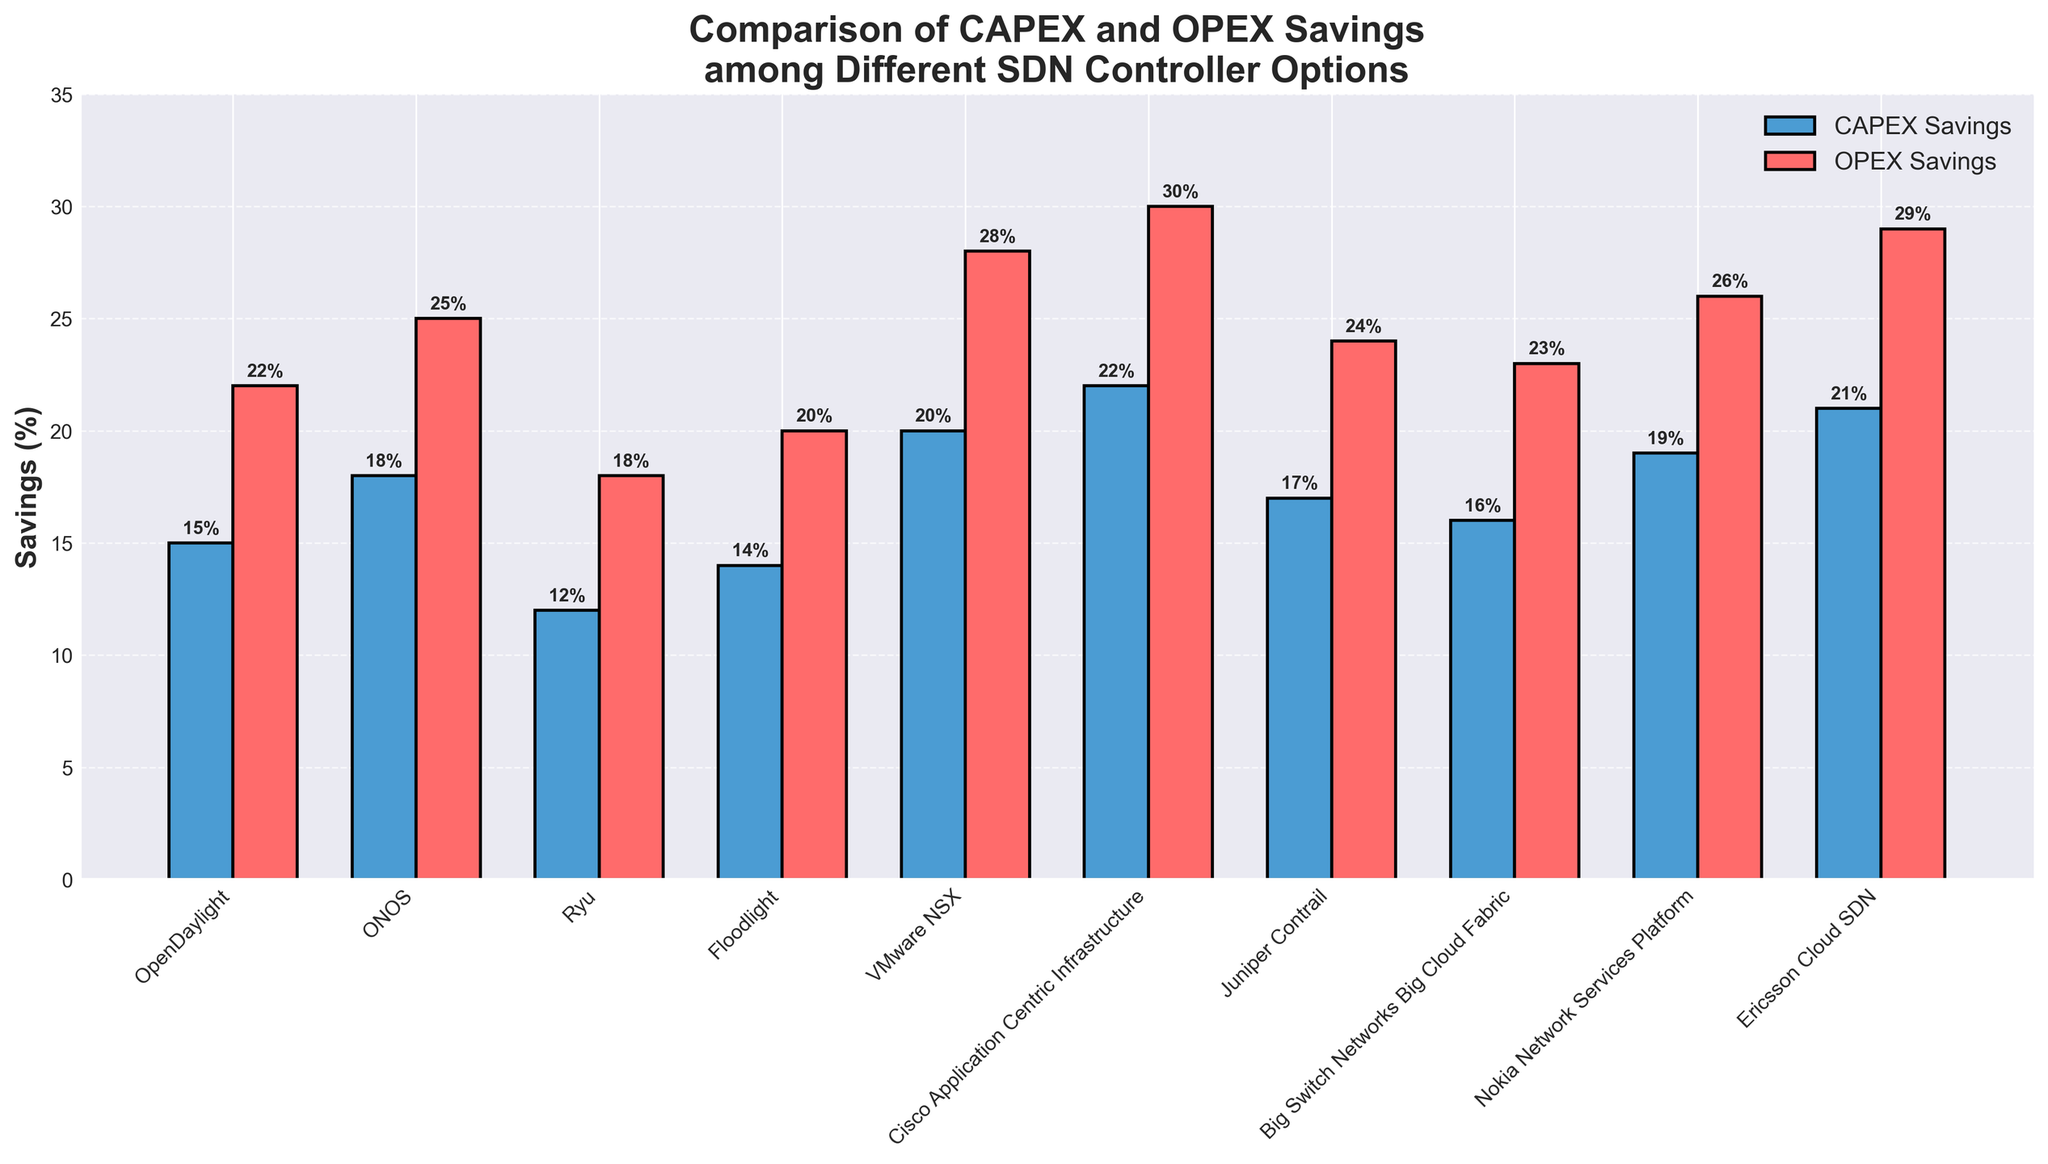How much greater are the OPEX savings of VMware NSX compared to Ryu? First, find the OPEX savings for VMware NSX (28%) and Ryu (18%). Subtract Ryu's OPEX savings from VMware NSX's OPEX savings: 28% - 18% = 10%.
Answer: 10% Which controller shows the highest CAPEX savings? Identify and compare CAPEX savings for all controllers. Cisco Application Centric Infrastructure has the highest CAPEX savings of 22%.
Answer: Cisco Application Centric Infrastructure Which controller has the smallest difference between CAPEX and OPEX savings? Calculate the difference between CAPEX and OPEX savings for each controller. The controller with the smallest difference is Ryu, with a difference of 6% (18% - 12%).
Answer: Ryu What is the average OPEX savings across all controllers? Add the OPEX savings percentages for all controllers and divide by the number of controllers (10). Sum = 265%, Average = 265% / 10 = 26.5%.
Answer: 26.5% Are the OPEX savings always higher than the CAPEX savings for each controller? Compare the OPEX and CAPEX savings for each controller. Yes, for all controllers, OPEX savings are higher than CAPEX savings.
Answer: Yes Which two controllers have the closest CAPEX savings? Compare the CAPEX saving percentages and look for the minimal difference. OpenDaylight and Floodlight have the closest CAPEX savings at 15% and 14%, respectively, yielding a difference of 1%.
Answer: OpenDaylight and Floodlight What is the total OPEX savings percentage for ONOS, Nokia Network Services Platform, and Ericsson Cloud SDN combined? Add the OPEX savings percentages for ONOS (25%), Nokia Network Services Platform (26%), and Ericsson Cloud SDN (29%). Sum = 25% + 26% + 29% = 80%.
Answer: 80% What's the difference in CAPEX savings between Cisco Application Centric Infrastructure and Big Switch Networks Big Cloud Fabric? Find the CAPEX savings for both controllers: Cisco Application Centric Infrastructure (22%) and Big Switch Networks Big Cloud Fabric (16%). Subtract Big Switch Networks Big Cloud Fabric's CAPEX savings from Cisco's: 22% - 16% = 6%.
Answer: 6% How many controllers have CAPEX savings of more than 15%? Identify controllers with CAPEX savings greater than 15%. These are ONOS, VMware NSX, Cisco Application Centric Infrastructure, Juniper Contrail, Nokia Network Services Platform, and Ericsson Cloud SDN. Total = 6 controllers.
Answer: 6 If the CAPEX savings for VMware NSX were increased by 3%, what would the new CAPEX savings be? VMware NSX's current CAPEX savings is 20%. Add 3%: 20% + 3% = 23%.
Answer: 23% 